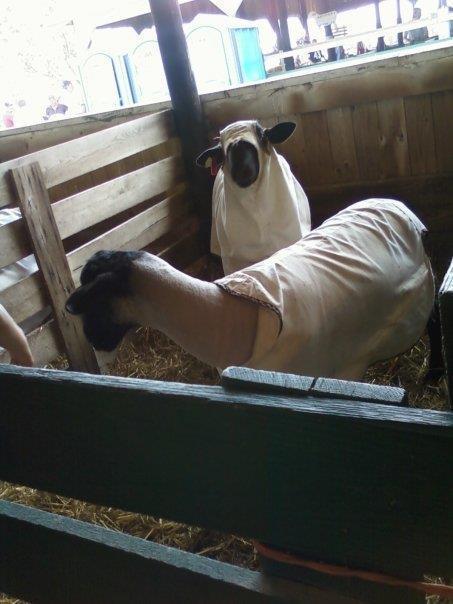What are the animals near?
Choose the right answer from the provided options to respond to the question.
Options: Egg cartons, apples, tree, fence. Fence. 